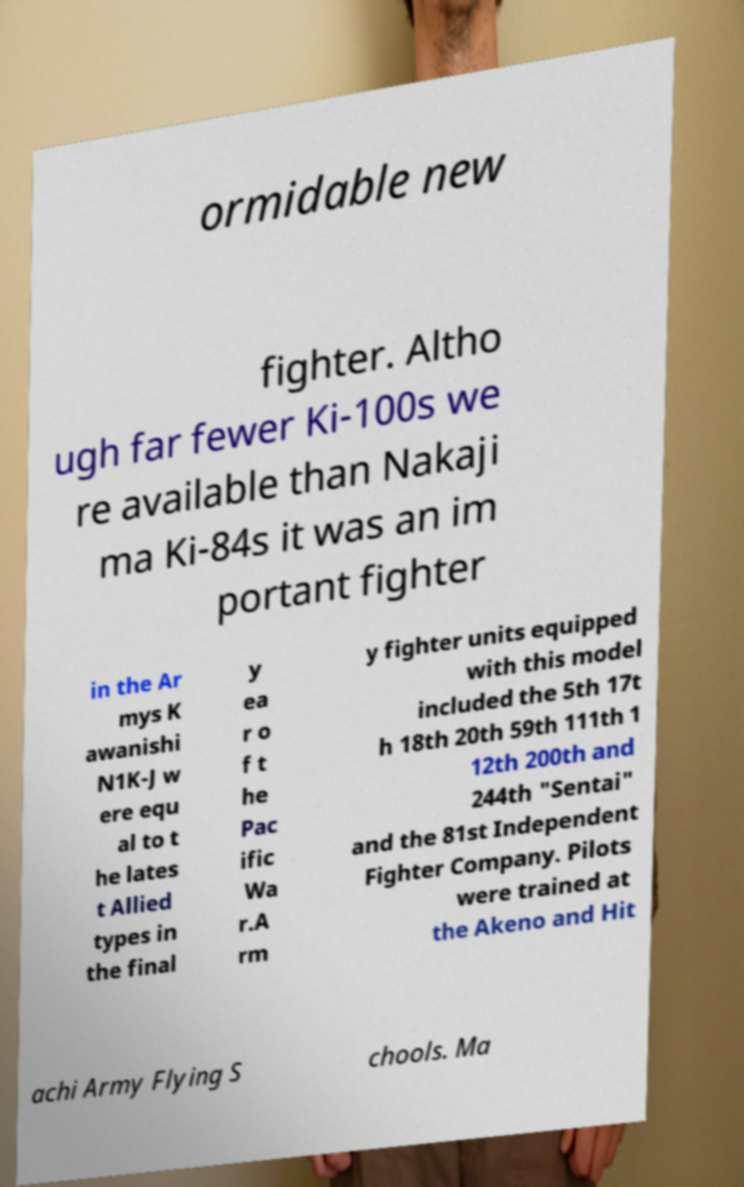Please identify and transcribe the text found in this image. ormidable new fighter. Altho ugh far fewer Ki-100s we re available than Nakaji ma Ki-84s it was an im portant fighter in the Ar mys K awanishi N1K-J w ere equ al to t he lates t Allied types in the final y ea r o f t he Pac ific Wa r.A rm y fighter units equipped with this model included the 5th 17t h 18th 20th 59th 111th 1 12th 200th and 244th "Sentai" and the 81st Independent Fighter Company. Pilots were trained at the Akeno and Hit achi Army Flying S chools. Ma 